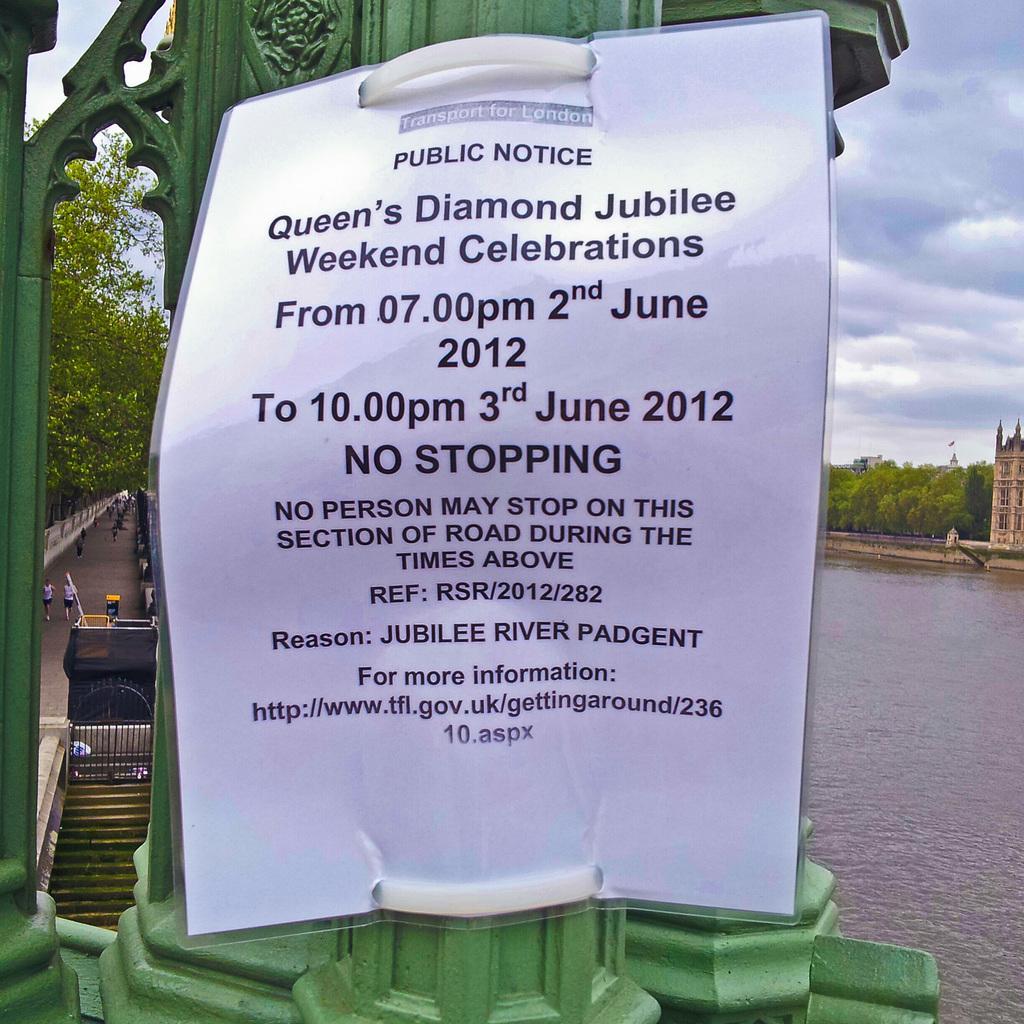Can you describe this image briefly? In this image I can see a huge metal pole which is green in color and a white colored broad attached to the pole. In the background I can see few stairs, the water, a building, few persons standing on the road, few trees and the sky. 